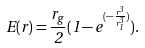Convert formula to latex. <formula><loc_0><loc_0><loc_500><loc_500>E ( r ) = \frac { r _ { g } } 2 ( 1 - e ^ { ( - \frac { r ^ { 3 } } { r _ { 1 } ^ { 3 } } ) } ) .</formula> 